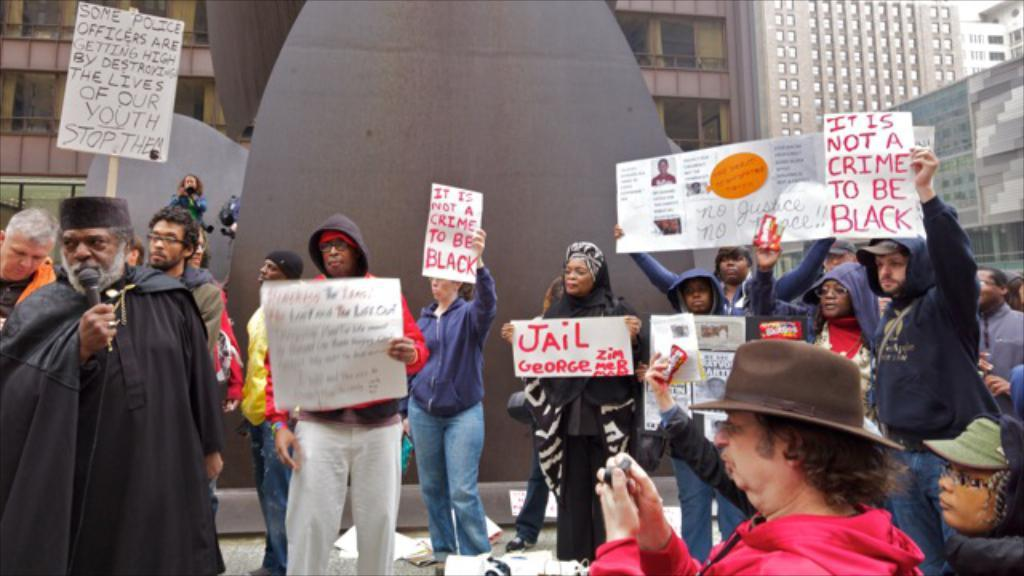What types of people are present in the image? There are men and women in the image. What are the people in the image doing? The people are standing in a protest. What are the protesters holding in the image? The protesters are holding whiteboards. What can be seen in the background of the image? There are buildings and a round shield visible in the background. What type of carriage can be seen transporting a jewel in the image? There is no carriage or jewel present in the image; it features a protest with people holding whiteboards. 